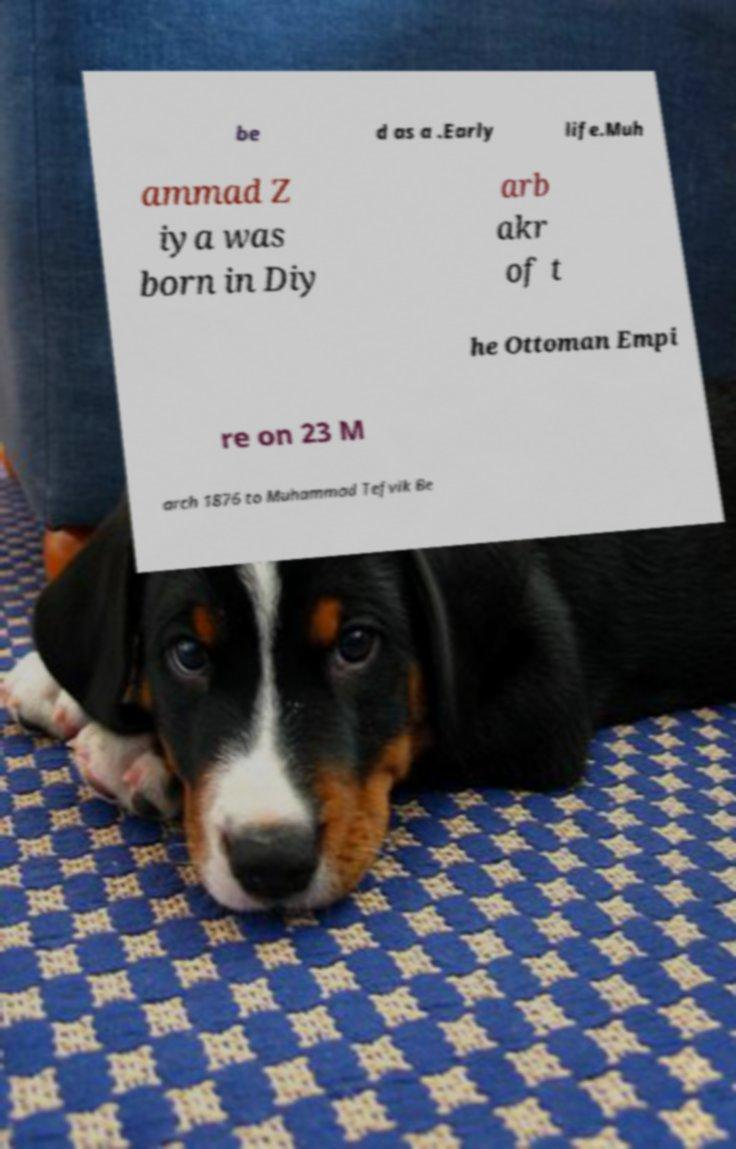Could you extract and type out the text from this image? be d as a .Early life.Muh ammad Z iya was born in Diy arb akr of t he Ottoman Empi re on 23 M arch 1876 to Muhammad Tefvik Be 